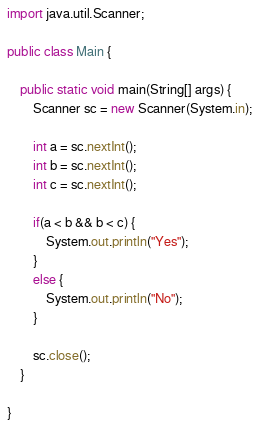Convert code to text. <code><loc_0><loc_0><loc_500><loc_500><_Java_>import java.util.Scanner;

public class Main {

	public static void main(String[] args) {
		Scanner sc = new Scanner(System.in);
		
		int a = sc.nextInt();
		int b = sc.nextInt();
		int c = sc.nextInt();
		
		if(a < b && b < c) {
			System.out.println("Yes");
		}
		else {
			System.out.println("No");
		}
		
		sc.close();
	}

}

</code> 